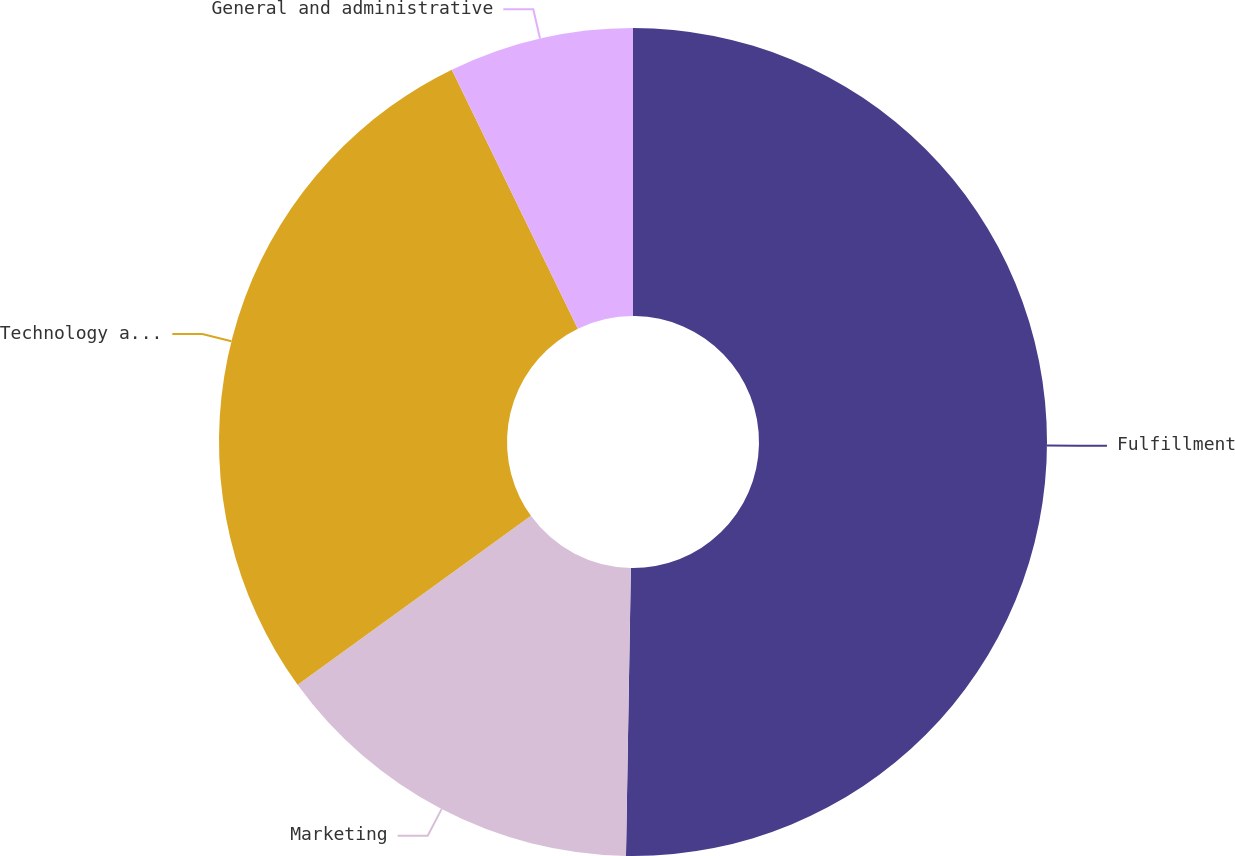<chart> <loc_0><loc_0><loc_500><loc_500><pie_chart><fcel>Fulfillment<fcel>Marketing<fcel>Technology and content<fcel>General and administrative<nl><fcel>50.27%<fcel>14.76%<fcel>27.76%<fcel>7.21%<nl></chart> 